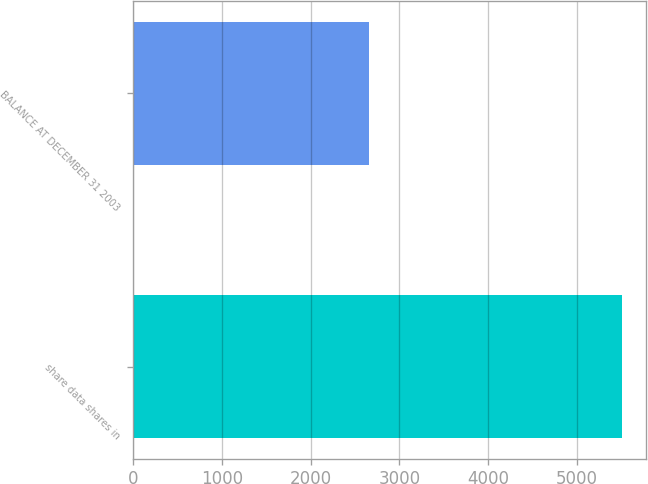Convert chart to OTSL. <chart><loc_0><loc_0><loc_500><loc_500><bar_chart><fcel>share data shares in<fcel>BALANCE AT DECEMBER 31 2003<nl><fcel>5508<fcel>2658<nl></chart> 